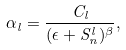<formula> <loc_0><loc_0><loc_500><loc_500>\alpha _ { l } = \frac { C _ { l } } { ( \epsilon + S _ { n } ^ { l } ) ^ { \beta } } ,</formula> 